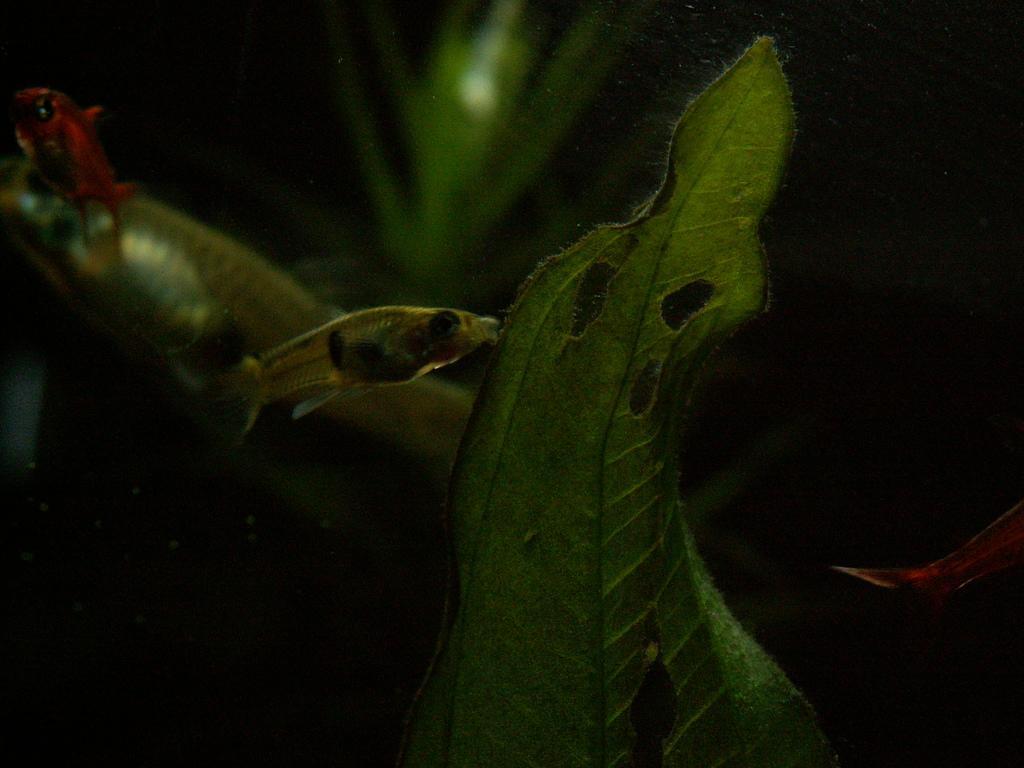Could you give a brief overview of what you see in this image? In the picture I can see a fish, a snake and a leaf. The background of the image is dark. 